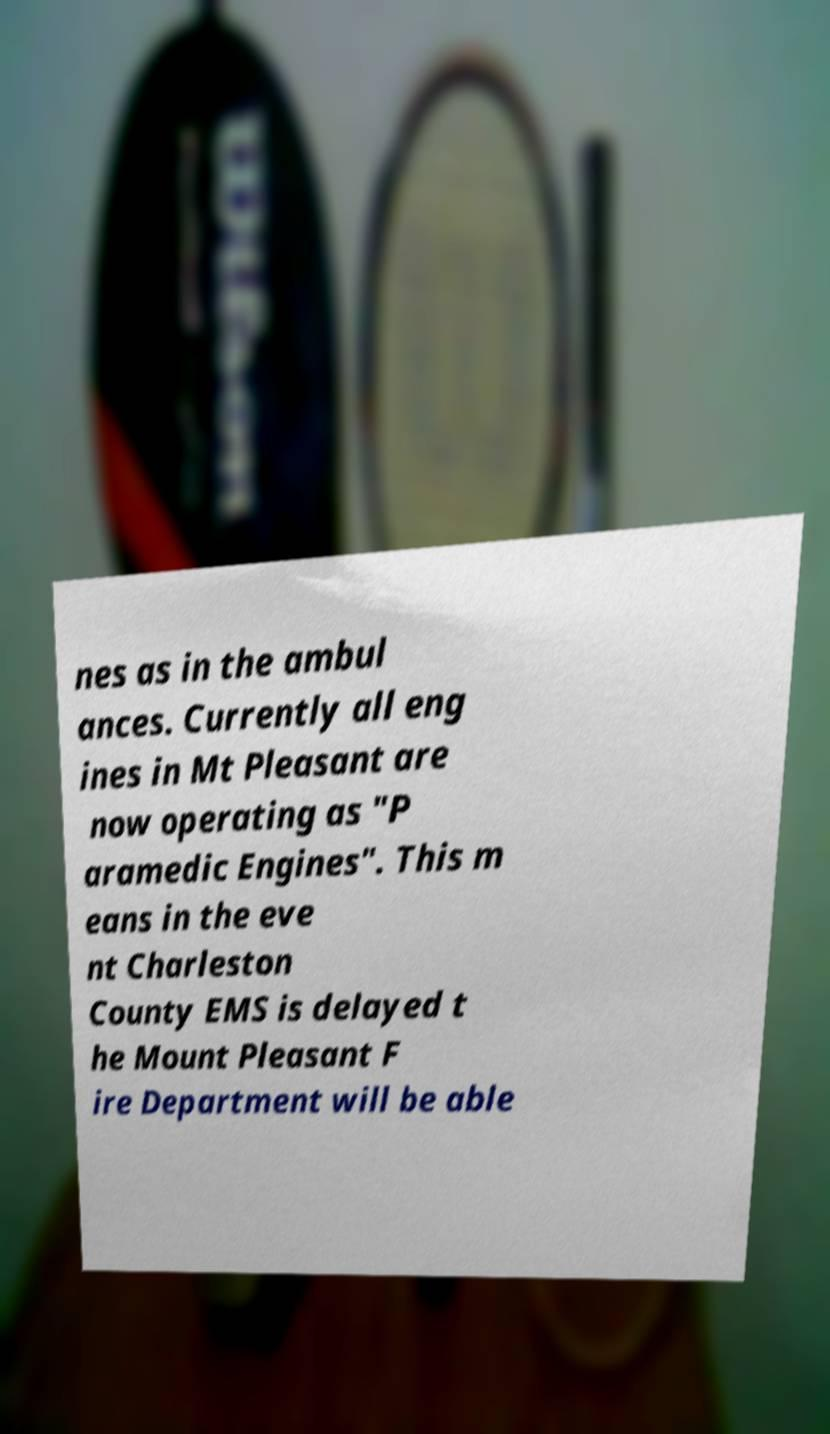Could you extract and type out the text from this image? nes as in the ambul ances. Currently all eng ines in Mt Pleasant are now operating as "P aramedic Engines". This m eans in the eve nt Charleston County EMS is delayed t he Mount Pleasant F ire Department will be able 